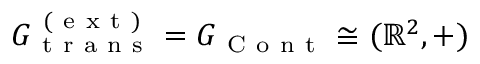Convert formula to latex. <formula><loc_0><loc_0><loc_500><loc_500>G _ { t r a n s } ^ { ( e x t ) } = G _ { C o n t } \cong ( \mathbb { R } ^ { 2 } , + )</formula> 